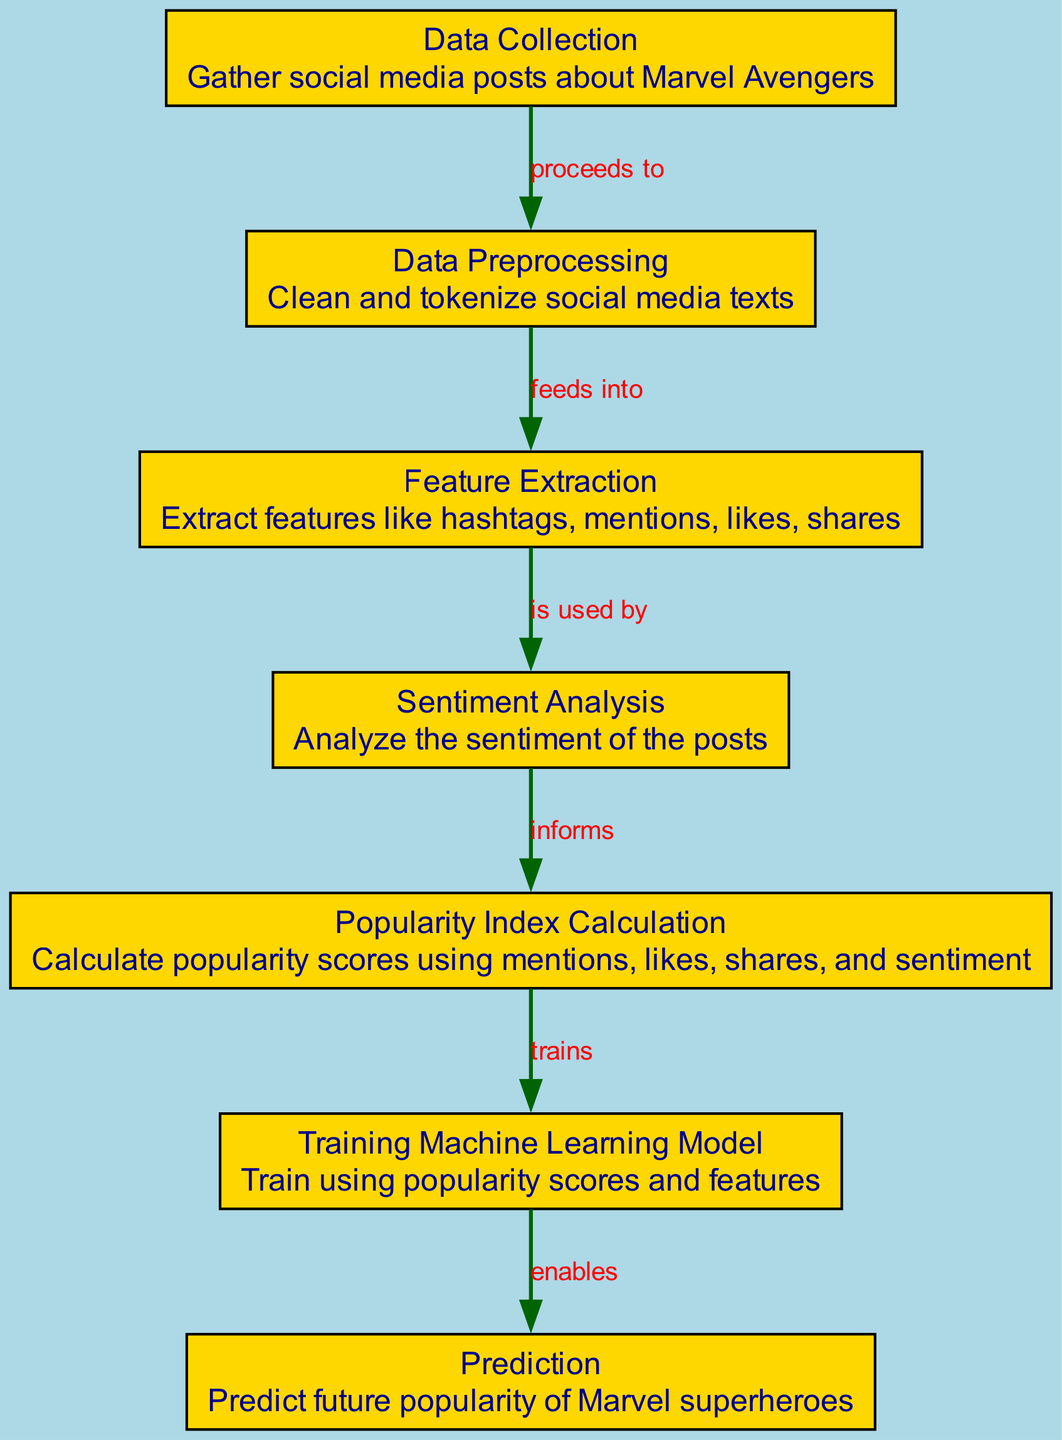What is the first step in the diagram? The diagram starts with the "Data Collection" node, which is labeled as "Gather social media posts about Marvel Avengers". This indicates that the first action is to collect data.
Answer: Data Collection How many nodes are in the diagram? By counting the listed nodes, there are 7 nodes in total that represent different stages of the process.
Answer: 7 What does the "Data Preprocessing" step feed into? According to the diagram, the "Data Preprocessing" step feeds into the "Feature Extraction" node, indicating it’s the next stage after preprocessing the data.
Answer: Feature Extraction What do we analyze in the "Sentiment Analysis" step? The purpose of the "Sentiment Analysis" node is to "Analyze the sentiment of the posts". This specifically means that the focus is on determining the emotional tone of the social media posts.
Answer: Sentiment What does the "Popularity Index Calculation" node inform? The "Popularity Index Calculation" step informs the "Training Machine Learning Model" node. This shows that the calculated popularity scores are utilized to train the model.
Answer: Training Machine Learning Model What is the last step of the process in the diagram? The final node in the flow of the diagram is "Prediction". This indicates that after all prior steps are complete, the ultimate goal is to predict future popularity.
Answer: Prediction How does "Training Machine Learning Model" relate to "Prediction"? The "Training Machine Learning Model" node enables the "Prediction" step, meaning it is essential for making future popularity predictions. This indicates a direct influence from training to prediction.
Answer: Enables What features are extracted in the "Feature Extraction" node? The "Feature Extraction" node is responsible for extracting features such as hashtags, mentions, likes, and shares from the social media data.
Answer: Hashtags, mentions, likes, shares What is the role of the "Popularity Index Calculation" in the process? The "Popularity Index Calculation" plays the crucial role of calculating popularity scores based on mentions, likes, shares, and sentiment analysis. It combines various metrics to determine popularity.
Answer: Calculate popularity scores 